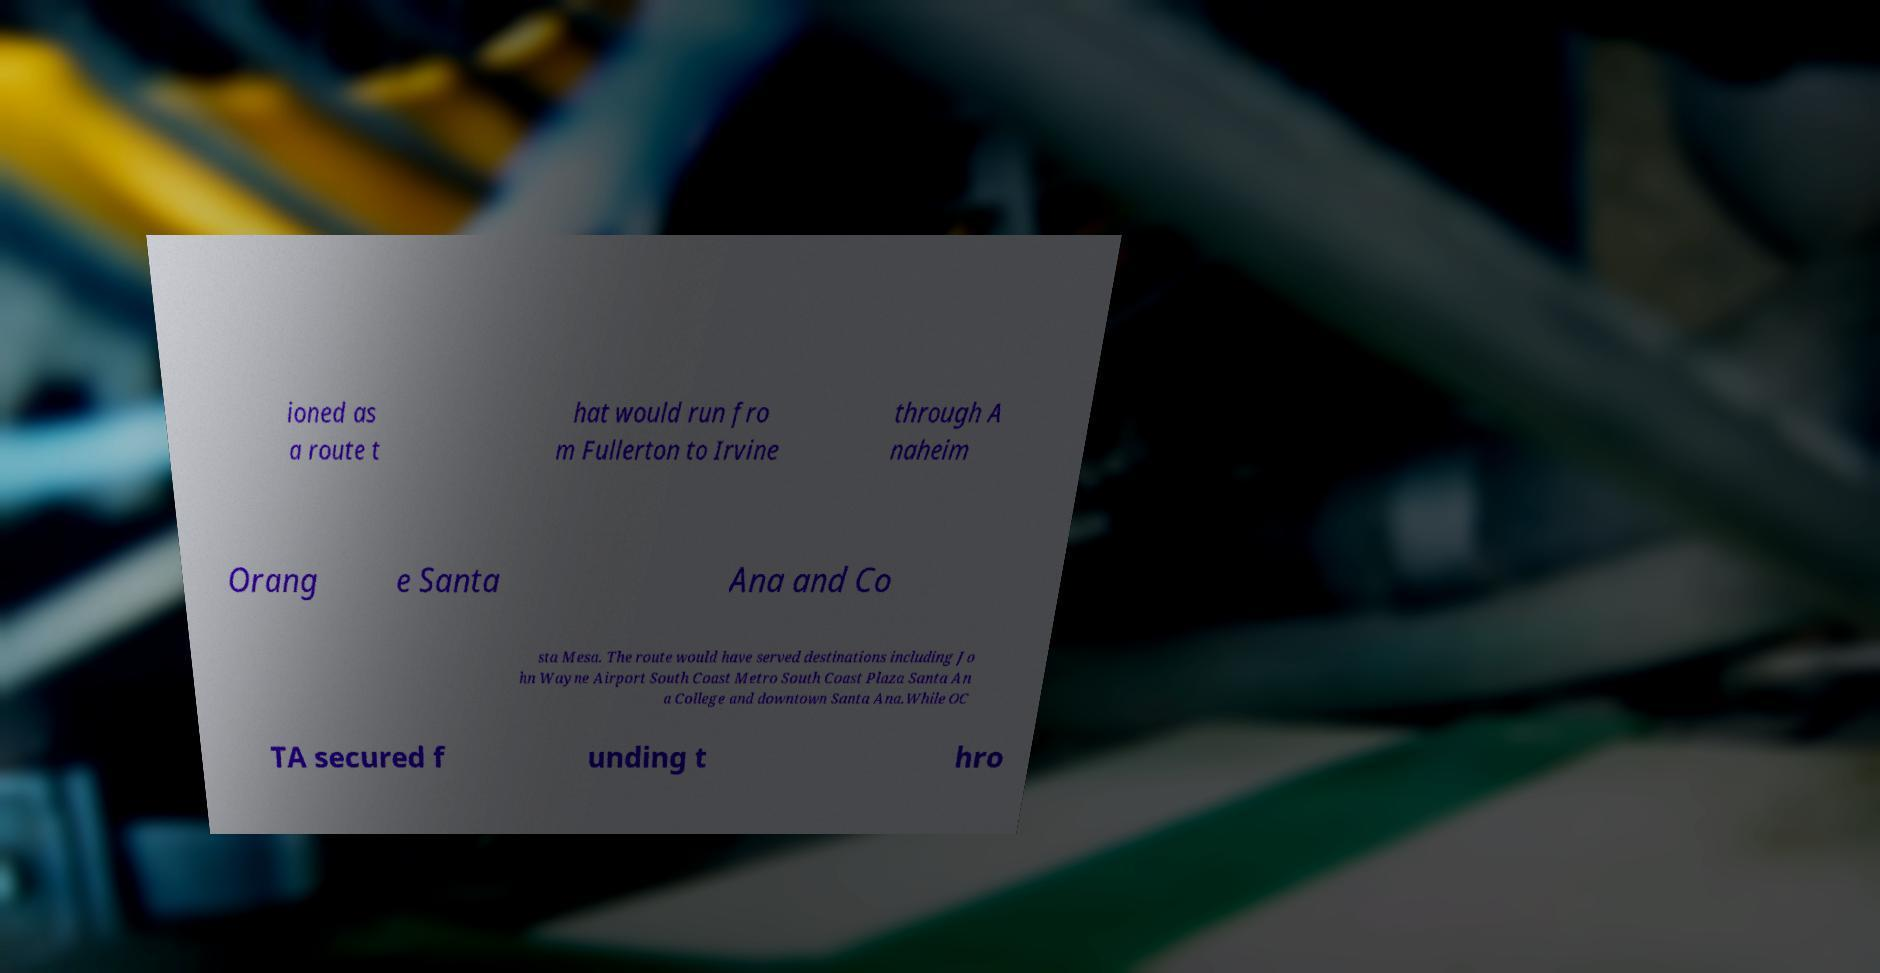Could you extract and type out the text from this image? ioned as a route t hat would run fro m Fullerton to Irvine through A naheim Orang e Santa Ana and Co sta Mesa. The route would have served destinations including Jo hn Wayne Airport South Coast Metro South Coast Plaza Santa An a College and downtown Santa Ana.While OC TA secured f unding t hro 